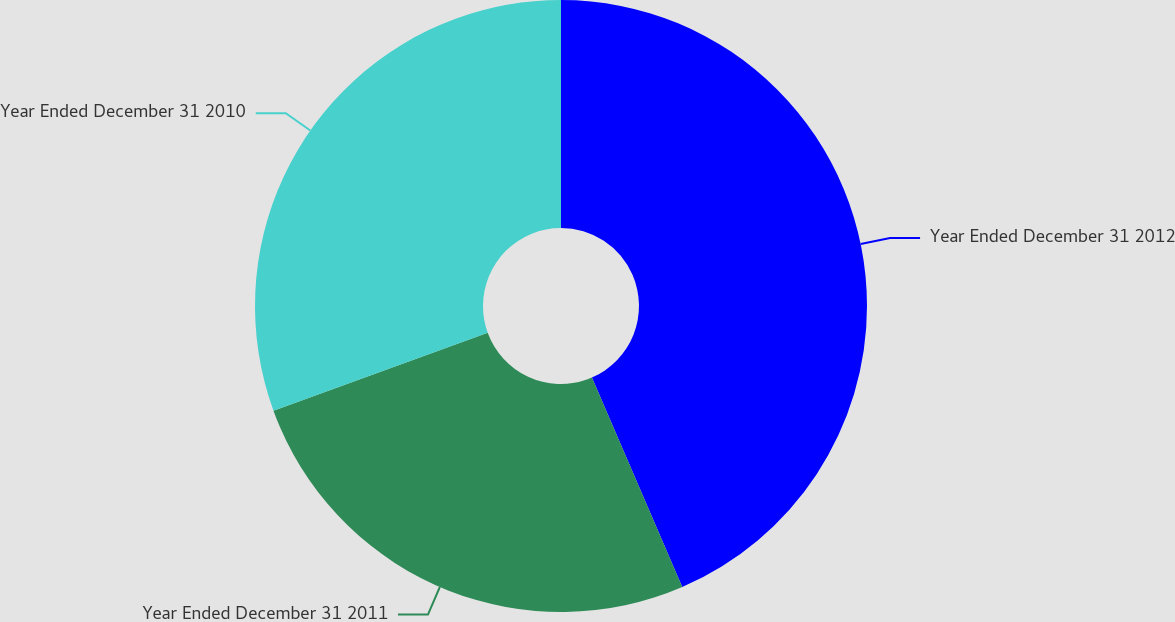Convert chart to OTSL. <chart><loc_0><loc_0><loc_500><loc_500><pie_chart><fcel>Year Ended December 31 2012<fcel>Year Ended December 31 2011<fcel>Year Ended December 31 2010<nl><fcel>43.52%<fcel>25.93%<fcel>30.56%<nl></chart> 